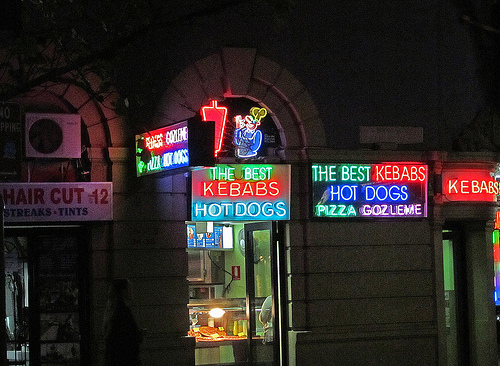<image>
Is the sign one behind the sign two? No. The sign one is not behind the sign two. From this viewpoint, the sign one appears to be positioned elsewhere in the scene. Where is the door in relation to the sign? Is it in front of the sign? No. The door is not in front of the sign. The spatial positioning shows a different relationship between these objects. 